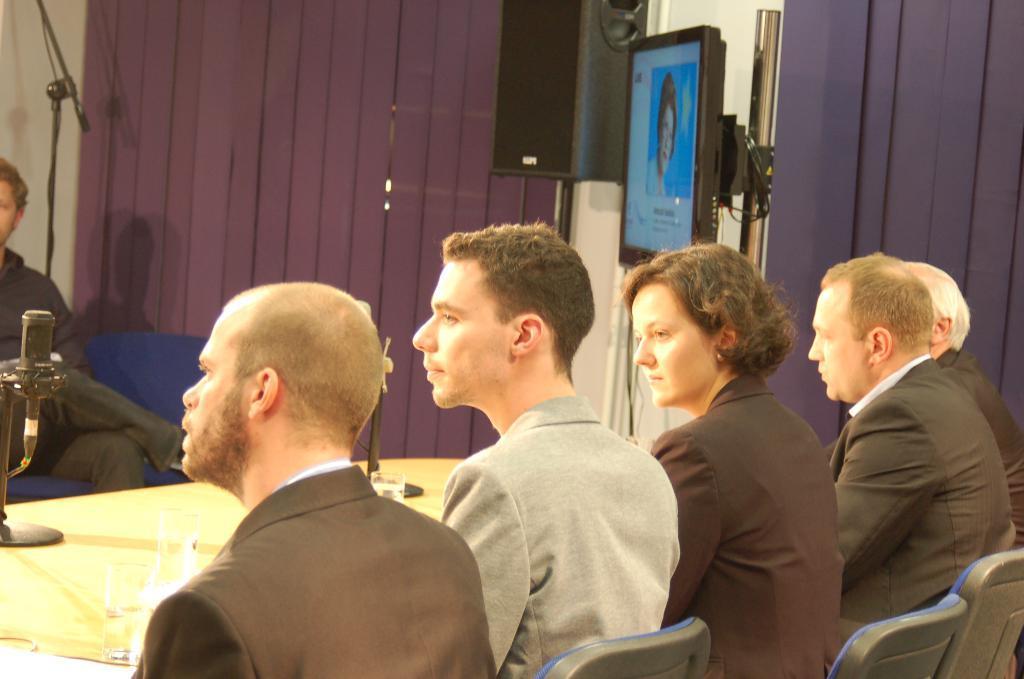Could you give a brief overview of what you see in this image? In this image there are few people sitting on the chairs. In front of them there is a table on which there is a mic in the middle. Beside the mic there are glasses. On the right side top there is a television. Beside the television there is a speaker. In the background there are curtains. 